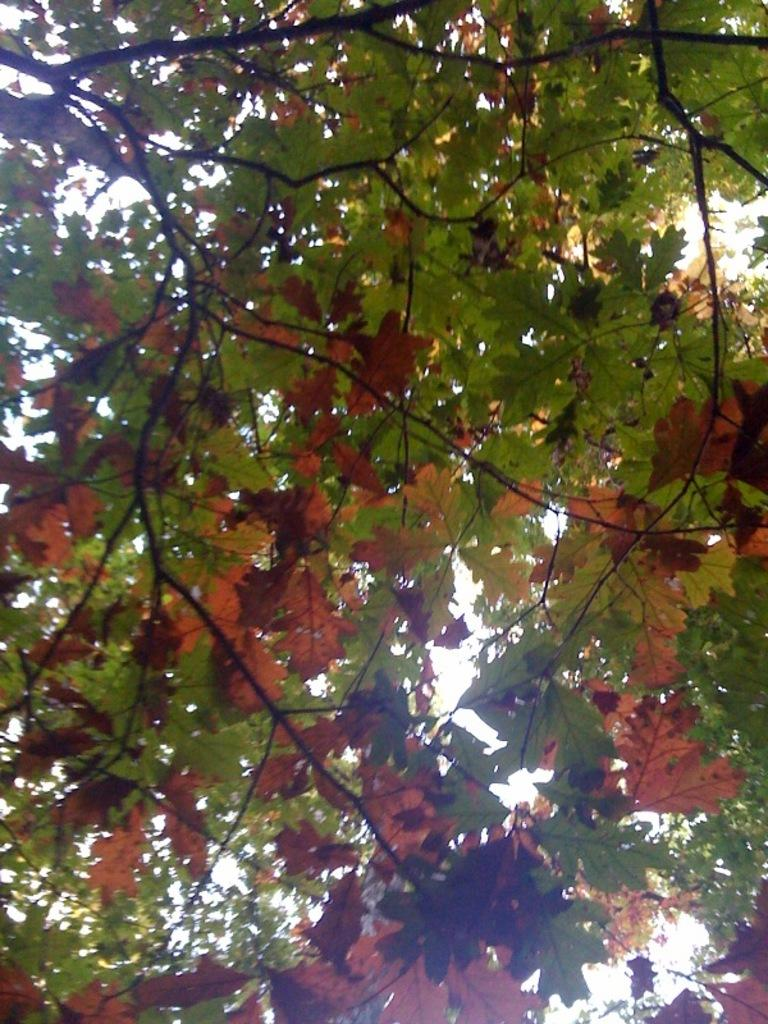What type of vegetation can be seen in the image? There are trees in the image. What colors are the leaves on the trees? The leaves on the trees have red and green colors. What part of the natural environment is visible in the image? The sky is visible in the image. What type of leather material can be seen hanging from the trees in the image? There is no leather material present in the image; the trees have leaves in red and green colors. What time of day is it in the image, considering the tin objects? There is no mention of tin objects in the image, and therefore it cannot be determined what time of day it is. 